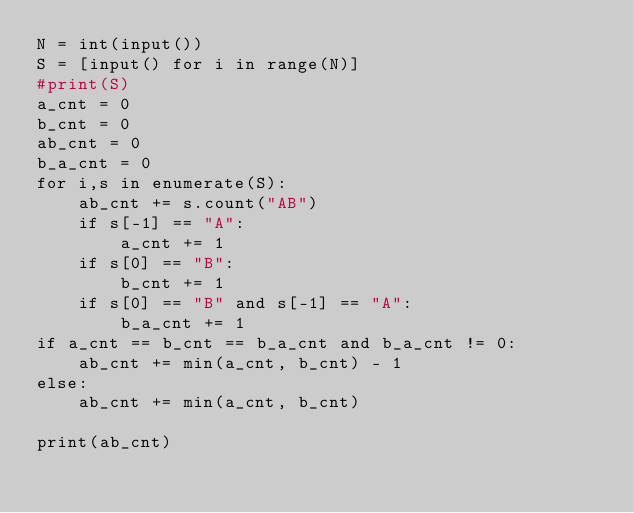<code> <loc_0><loc_0><loc_500><loc_500><_Python_>N = int(input())
S = [input() for i in range(N)]
#print(S)
a_cnt = 0
b_cnt = 0
ab_cnt = 0
b_a_cnt = 0
for i,s in enumerate(S):
    ab_cnt += s.count("AB")
    if s[-1] == "A":
        a_cnt += 1
    if s[0] == "B":
        b_cnt += 1
    if s[0] == "B" and s[-1] == "A":
        b_a_cnt += 1
if a_cnt == b_cnt == b_a_cnt and b_a_cnt != 0:
    ab_cnt += min(a_cnt, b_cnt) - 1
else:
    ab_cnt += min(a_cnt, b_cnt)

print(ab_cnt)</code> 